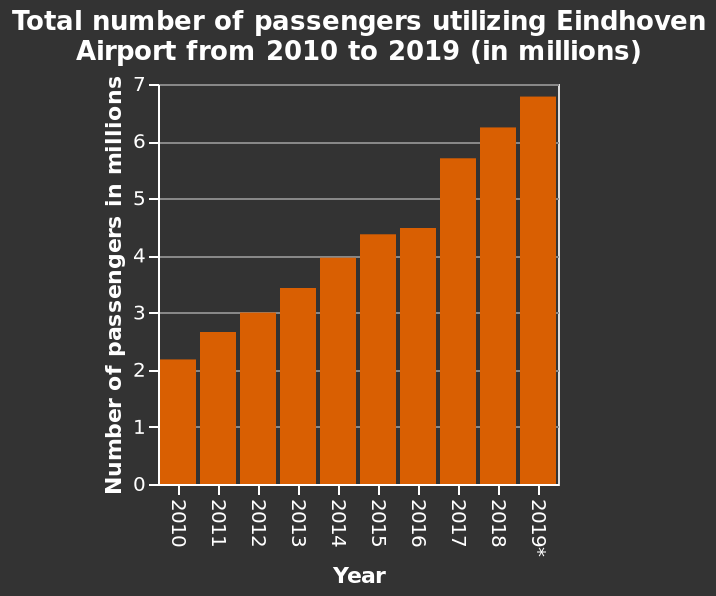<image>
What was the trend in the numbers visiting before 2015/16?  The numbers visiting increased significantly before 2015/16. How many passengers were there in total for the year 2012? Approximately 3 million passengers were recorded at Eindhoven Airport in the year 2012, based on the bar graph. What was the total number of passengers utilizing Eindhoven Airport in 2015? According to the bar graph, the total number of passengers utilizing Eindhoven Airport in 2015 was approximately 4.5 million. 